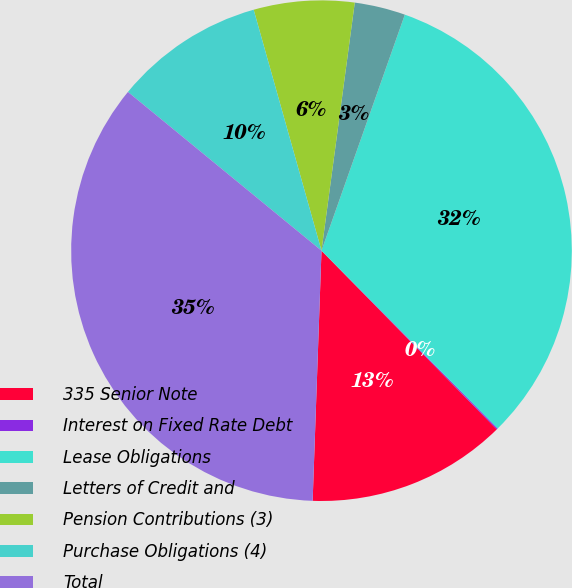Convert chart. <chart><loc_0><loc_0><loc_500><loc_500><pie_chart><fcel>335 Senior Note<fcel>Interest on Fixed Rate Debt<fcel>Lease Obligations<fcel>Letters of Credit and<fcel>Pension Contributions (3)<fcel>Purchase Obligations (4)<fcel>Total<nl><fcel>12.91%<fcel>0.08%<fcel>32.17%<fcel>3.28%<fcel>6.49%<fcel>9.7%<fcel>35.37%<nl></chart> 